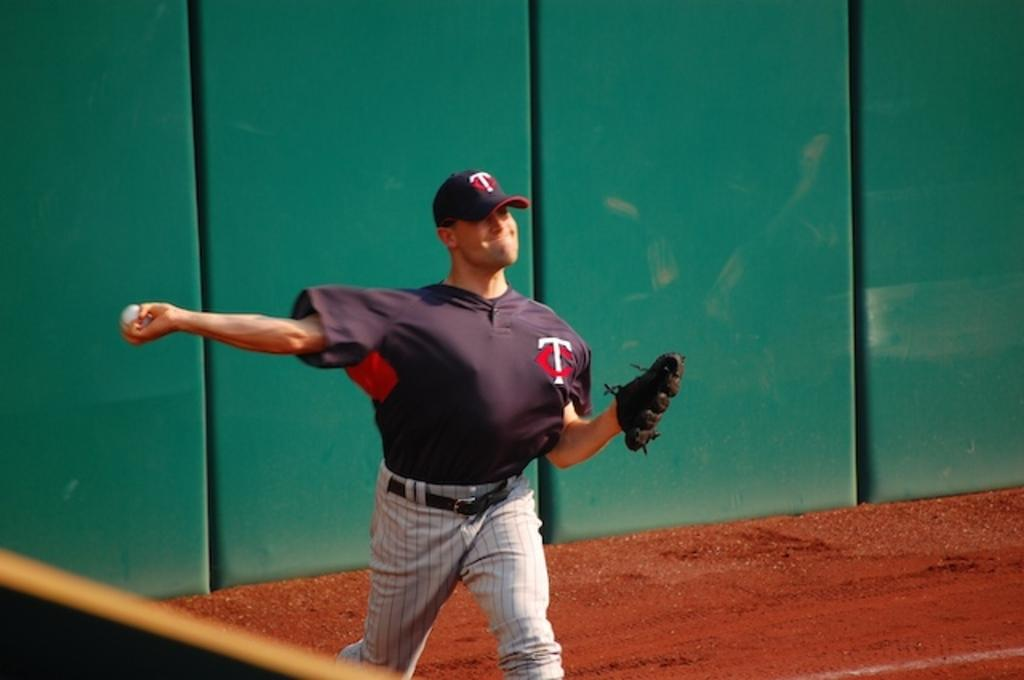<image>
Share a concise interpretation of the image provided. A baseball player with a white "T" on his hat is throwing a baseball. 